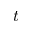Convert formula to latex. <formula><loc_0><loc_0><loc_500><loc_500>t</formula> 